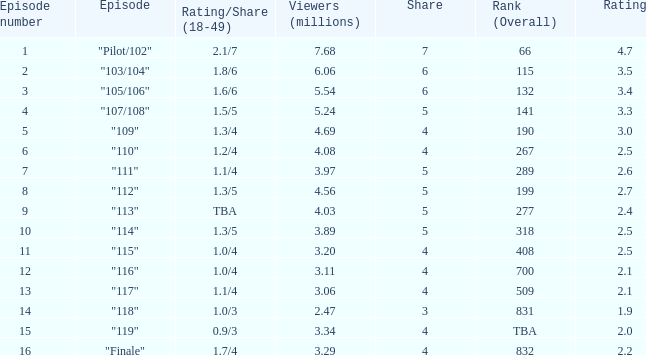WHAT IS THE RATING THAT HAD A SHARE SMALLER THAN 4, AND 2.47 MILLION VIEWERS? 0.0. 